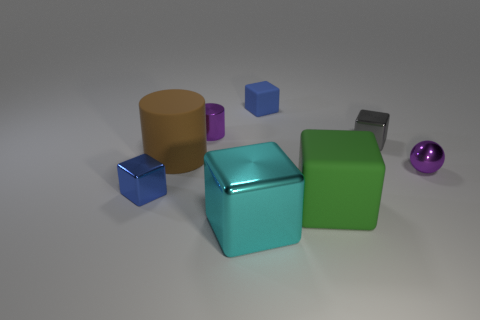There is a purple object that is on the right side of the green rubber cube; what is its size?
Your answer should be compact. Small. There is a gray thing that is the same size as the metal ball; what material is it?
Provide a short and direct response. Metal. Do the cyan object and the brown object have the same shape?
Ensure brevity in your answer.  No. How many things are either cyan shiny cubes or cubes that are right of the small blue metal cube?
Offer a terse response. 4. There is a small thing that is the same color as the metal ball; what is its material?
Ensure brevity in your answer.  Metal. There is a blue cube that is behind the shiny sphere; does it have the same size as the tiny purple ball?
Your answer should be very brief. Yes. There is a big cube that is right of the metal thing in front of the blue metal thing; what number of large matte blocks are behind it?
Your answer should be compact. 0. How many purple objects are tiny spheres or small shiny cylinders?
Offer a terse response. 2. The big object that is made of the same material as the tiny ball is what color?
Give a very brief answer. Cyan. How many big things are cyan metallic spheres or shiny spheres?
Keep it short and to the point. 0. 